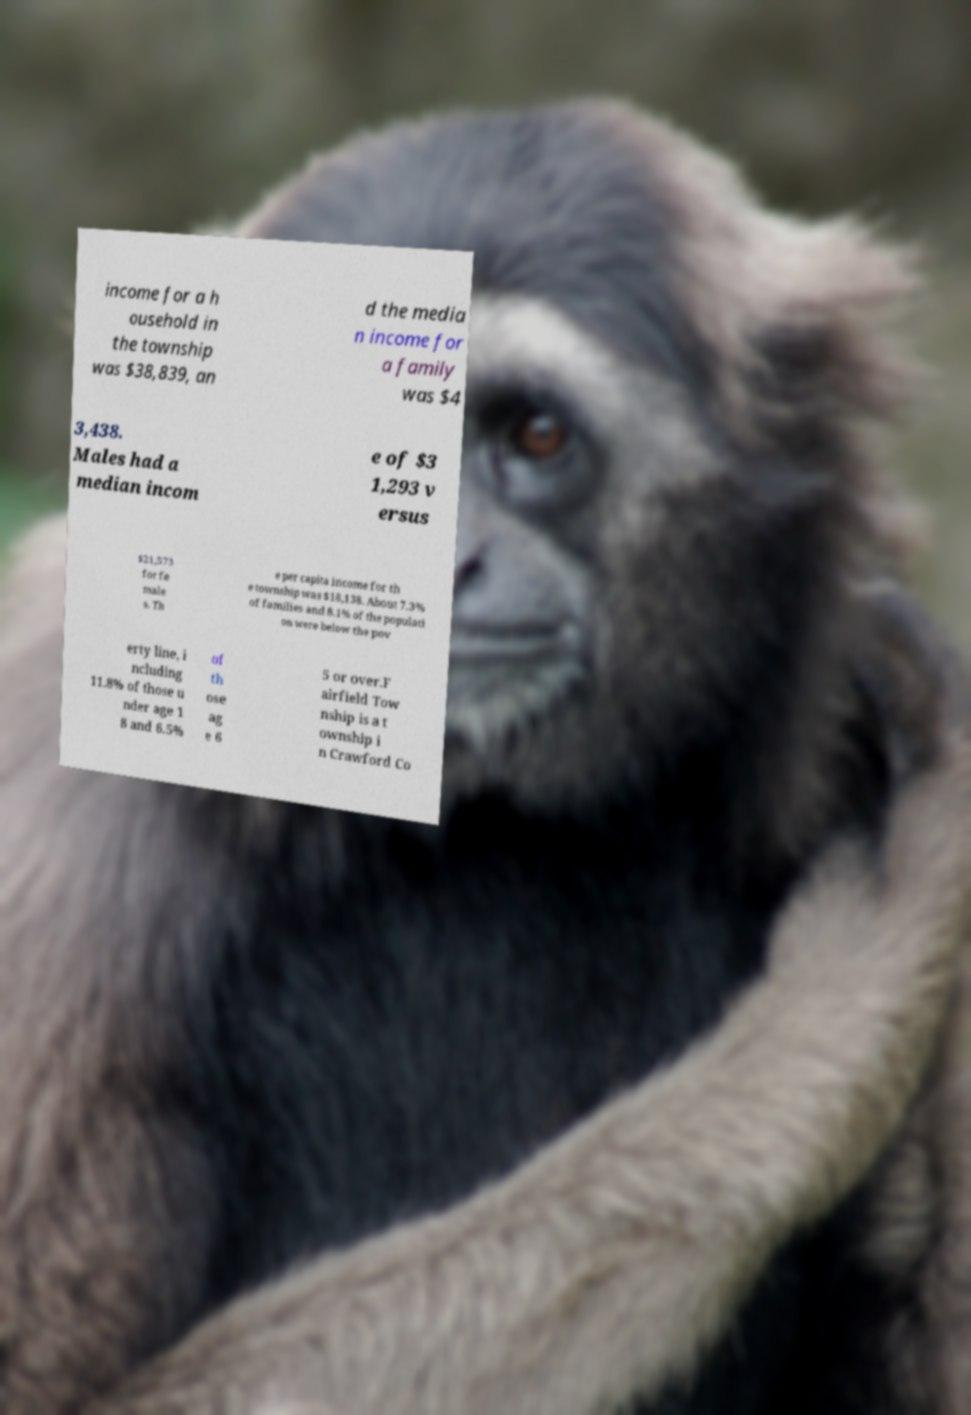What messages or text are displayed in this image? I need them in a readable, typed format. income for a h ousehold in the township was $38,839, an d the media n income for a family was $4 3,438. Males had a median incom e of $3 1,293 v ersus $21,573 for fe male s. Th e per capita income for th e township was $18,138. About 7.3% of families and 8.1% of the populati on were below the pov erty line, i ncluding 11.8% of those u nder age 1 8 and 6.5% of th ose ag e 6 5 or over.F airfield Tow nship is a t ownship i n Crawford Co 